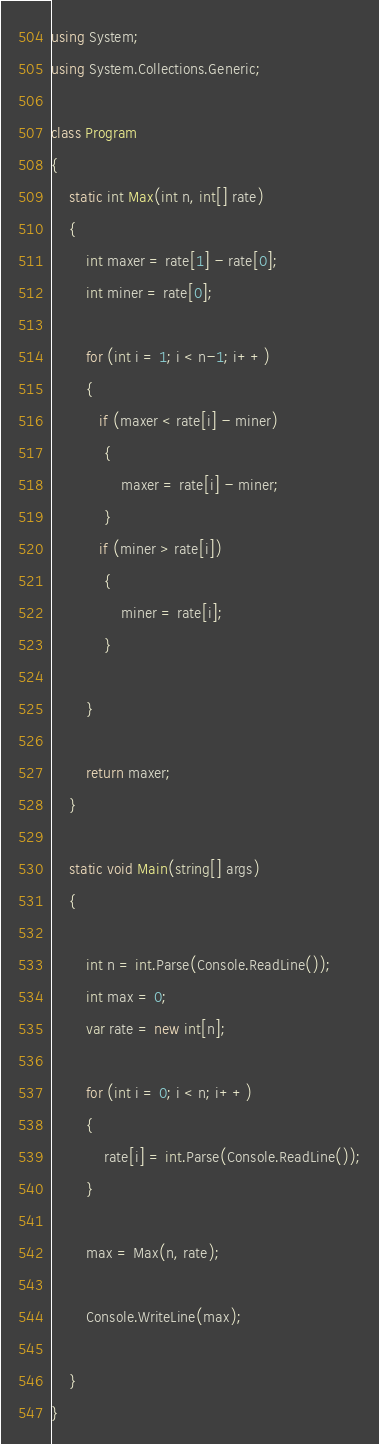<code> <loc_0><loc_0><loc_500><loc_500><_C#_>using System;
using System.Collections.Generic;

class Program
{
    static int Max(int n, int[] rate)
    {
        int maxer = rate[1] - rate[0];
        int miner = rate[0];

        for (int i = 1; i < n-1; i++)
        {
           if (maxer < rate[i] - miner)
            {
                maxer = rate[i] - miner;
            }
           if (miner > rate[i])
            {
                miner = rate[i];
            }

        }

        return maxer;
    }

    static void Main(string[] args)
    {

        int n = int.Parse(Console.ReadLine());
        int max = 0;
        var rate = new int[n];
        
        for (int i = 0; i < n; i++)
        {
            rate[i] = int.Parse(Console.ReadLine());
        }

        max = Max(n, rate);

        Console.WriteLine(max);       

    }
}
</code> 